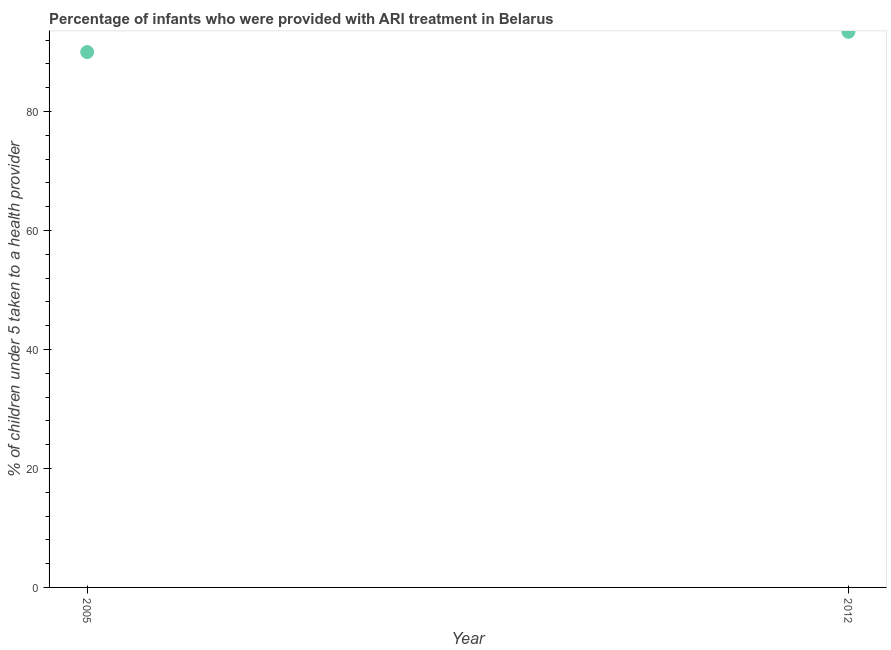What is the percentage of children who were provided with ari treatment in 2012?
Provide a short and direct response. 93.4. Across all years, what is the maximum percentage of children who were provided with ari treatment?
Ensure brevity in your answer.  93.4. In which year was the percentage of children who were provided with ari treatment maximum?
Provide a short and direct response. 2012. What is the sum of the percentage of children who were provided with ari treatment?
Your response must be concise. 183.4. What is the difference between the percentage of children who were provided with ari treatment in 2005 and 2012?
Offer a terse response. -3.4. What is the average percentage of children who were provided with ari treatment per year?
Provide a succinct answer. 91.7. What is the median percentage of children who were provided with ari treatment?
Provide a short and direct response. 91.7. Do a majority of the years between 2005 and 2012 (inclusive) have percentage of children who were provided with ari treatment greater than 8 %?
Your response must be concise. Yes. What is the ratio of the percentage of children who were provided with ari treatment in 2005 to that in 2012?
Your response must be concise. 0.96. Does the percentage of children who were provided with ari treatment monotonically increase over the years?
Your answer should be compact. Yes. How many years are there in the graph?
Make the answer very short. 2. What is the difference between two consecutive major ticks on the Y-axis?
Keep it short and to the point. 20. Are the values on the major ticks of Y-axis written in scientific E-notation?
Offer a very short reply. No. What is the title of the graph?
Provide a short and direct response. Percentage of infants who were provided with ARI treatment in Belarus. What is the label or title of the X-axis?
Your answer should be compact. Year. What is the label or title of the Y-axis?
Provide a succinct answer. % of children under 5 taken to a health provider. What is the % of children under 5 taken to a health provider in 2005?
Your answer should be very brief. 90. What is the % of children under 5 taken to a health provider in 2012?
Provide a succinct answer. 93.4. What is the difference between the % of children under 5 taken to a health provider in 2005 and 2012?
Provide a succinct answer. -3.4. What is the ratio of the % of children under 5 taken to a health provider in 2005 to that in 2012?
Your answer should be compact. 0.96. 